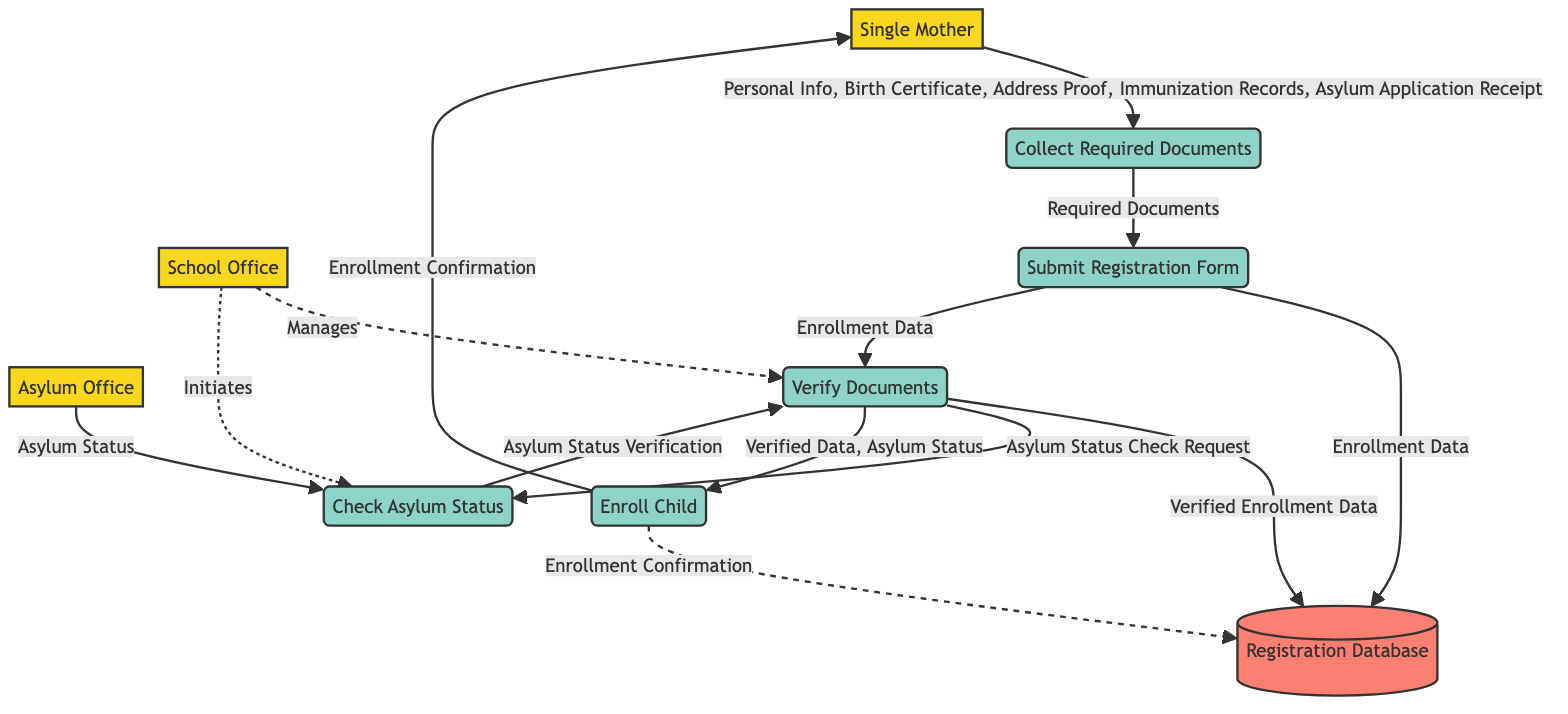What is the first process in the enrollment sequence? The first process depicted in the diagram is "Collect Required Documents." This is confirmed by tracing the flow from the "Single Mother," who initiates the process leading to the first step of collecting necessary documents.
Answer: Collect Required Documents How many entities are present in the diagram? The diagram includes three distinct entities: "Single Mother," "School Office," and "Asylum Office." Counting each one confirms there are three entities present in the diagram.
Answer: Three What type of data does the "Submit Registration Form" process handle? The "Submit Registration Form" process handles "Enrollment Data" as its output. This is shown in the diagram where it directly connects to "Registration Database" and "Verify Documents" with the noted output.
Answer: Enrollment Data Which process checks the asylum status with the Asylum Office? The process that checks the asylum status with the Asylum Office is "Check Asylum Status." This is evident as it directly connects the "School Office" with the "Asylum Office" to verify the status.
Answer: Check Asylum Status What is the final output upon successful enrollment of the child? The final output upon the successful enrollment of the child is "Enrollment Confirmation." This is indicated as the last step in the flow, leading to the "Single Mother" and the "Registration Database."
Answer: Enrollment Confirmation Which entity is responsible for verifying documents? The entity responsible for verifying documents is the "School Office." The diagram shows that the "Verify Documents" process is managed by the "School Office," which confirms document authenticity.
Answer: School Office What data is sent back from the Asylum Office to the Check Asylum Status process? The data sent back from the Asylum Office to the Check Asylum Status process is "Asylum Status." This is indicated by the arrow that shows data flowing from the "Asylum Office" to the "Check Asylum Status" process.
Answer: Asylum Status What happens if the verification of documents is unsuccessful? The diagram does not explicitly state what occurs if verification is unsuccessful; however, it implies that the process would not lead to "Enroll Child." This logical reasoning is drawn from the flow, suggesting that the enrollment cannot proceed without verified data.
Answer: Not specified in the diagram 